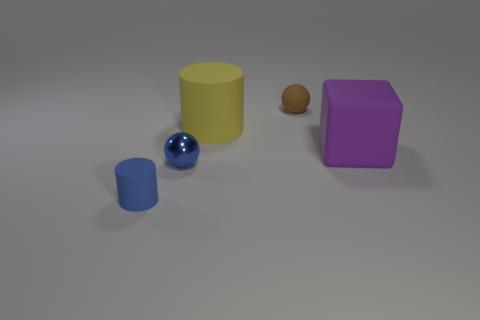Is there anything else that is made of the same material as the blue sphere?
Your answer should be very brief. No. What number of big objects are there?
Give a very brief answer. 2. The matte cylinder that is behind the tiny shiny thing is what color?
Your response must be concise. Yellow. What size is the purple thing?
Give a very brief answer. Large. Do the matte cube and the small ball that is left of the tiny matte sphere have the same color?
Offer a terse response. No. What is the color of the tiny ball in front of the tiny thing that is to the right of the big matte cylinder?
Ensure brevity in your answer.  Blue. Are there any other things that have the same size as the blue metallic ball?
Your response must be concise. Yes. Do the blue thing behind the blue cylinder and the blue matte thing have the same shape?
Give a very brief answer. No. How many matte objects are in front of the tiny brown object and to the right of the yellow cylinder?
Ensure brevity in your answer.  1. What color is the small object that is right of the large thing that is behind the object to the right of the brown sphere?
Provide a succinct answer. Brown. 